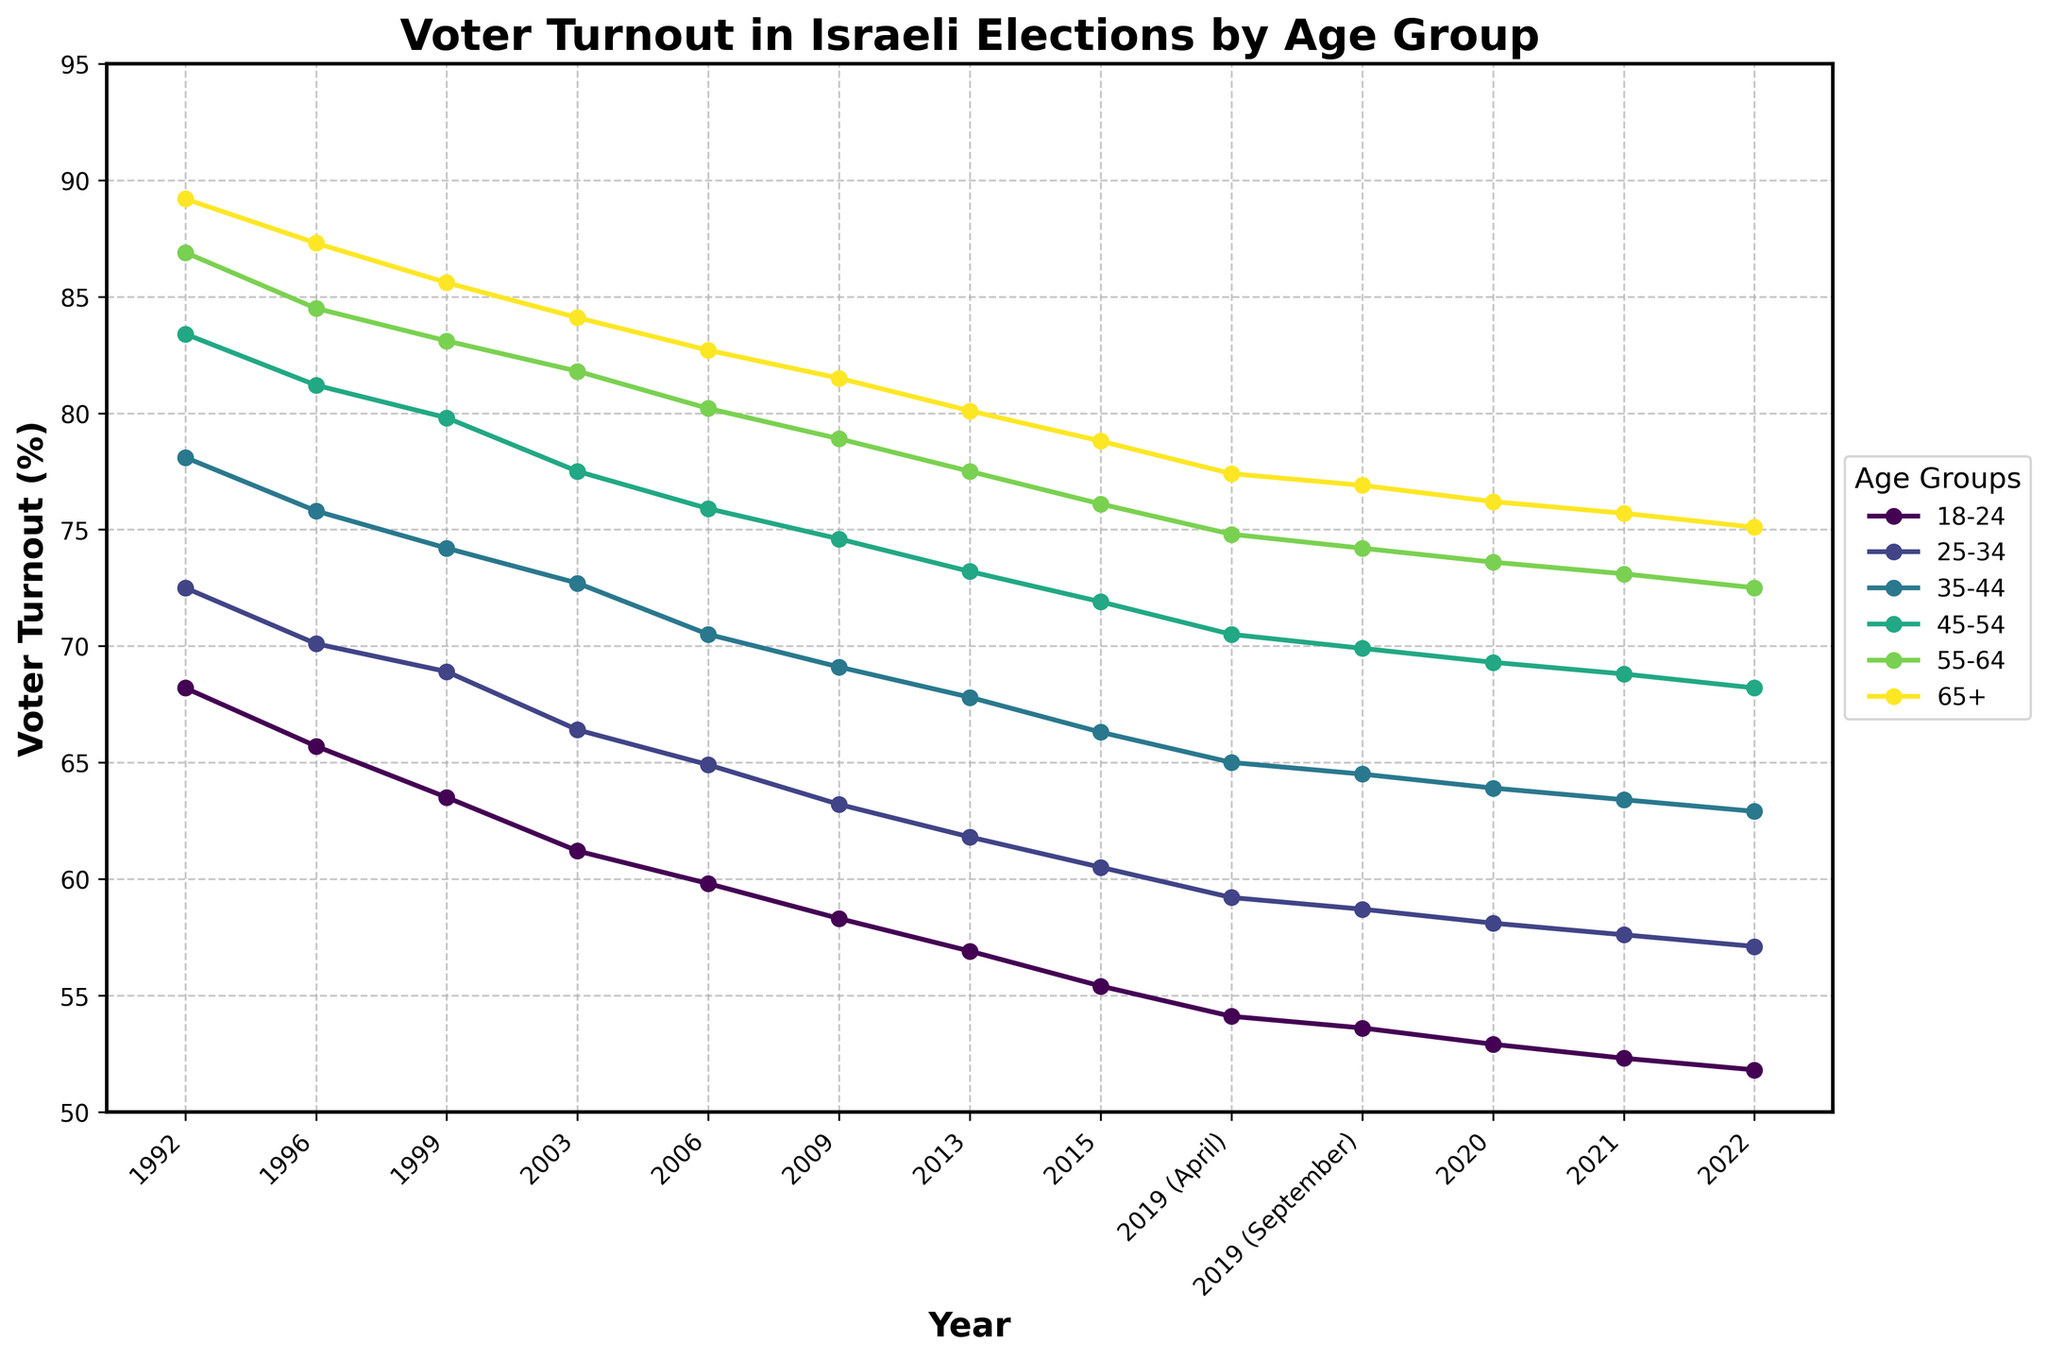What is the voter turnout percentage for the 65+ age group in the year 2003? Look at the data line for the year 2003 and find the corresponding value in the 65+ age group.
Answer: 84.1 Compare the voter turnout between the 18-24 and 55-64 age groups in the year 2020. Which group had a higher turnout and by how much? Locate the year 2020 on the x-axis, then find the voter turnout values for both the 18-24 and 55-64 age groups. Subtract the turnout percentage for the 18-24 age group from the 55-64 age group.
Answer: 55-64 by 20.7 When did the 18-24 age group have the highest voter turnout? Identify the peak value for the 18-24 age group line and check the corresponding year on the x-axis.
Answer: 1992 By how much did the voter turnout change for the 35-44 age group from 1992 to 2022? Find the voter turnout values for the 35-44 age group in 1992 and 2022. Subtract the 2022 value from the 1992 value to find the change.
Answer: Decreased by 15.2 Which age group consistently shows the highest voter turnout across all years? Observe all the lines, noting which one is consistently at the top across the x-axis.
Answer: 65+ What is the general trend in voter turnout for the 25-34 age group from 1992 to 2022? Look at the line for the 25-34 age group and observe the direction and pattern from 1992 to 2022.
Answer: Decreasing How much did the voter turnout percentage for the 45-54 age group change from 2019 (April) to 2019 (September)? Find the voter turnout percentages for the 45-54 age group in April and September 2019, then subtract the September value from the April value.
Answer: Decreased by 0.6 Which age group experienced the steepest decline in voter turnout between 1992 and 2022? By comparing the decline in voter turnout from 1992 to 2022 across all age groups, identify the group with the largest drop.
Answer: 18-24 In the year 2022, which two age groups had voter turnouts closest to each other? Check the voter turnout values for all age groups in 2022 and find the pair with the smallest difference.
Answer: 45-54 and 55-64 